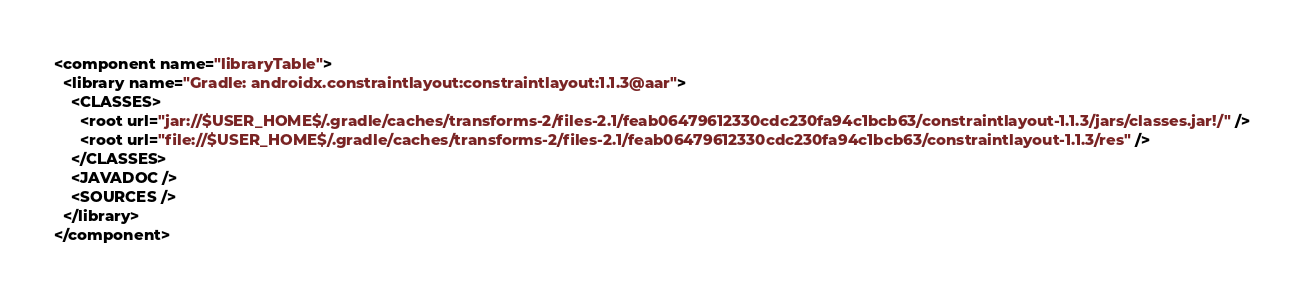Convert code to text. <code><loc_0><loc_0><loc_500><loc_500><_XML_><component name="libraryTable">
  <library name="Gradle: androidx.constraintlayout:constraintlayout:1.1.3@aar">
    <CLASSES>
      <root url="jar://$USER_HOME$/.gradle/caches/transforms-2/files-2.1/feab06479612330cdc230fa94c1bcb63/constraintlayout-1.1.3/jars/classes.jar!/" />
      <root url="file://$USER_HOME$/.gradle/caches/transforms-2/files-2.1/feab06479612330cdc230fa94c1bcb63/constraintlayout-1.1.3/res" />
    </CLASSES>
    <JAVADOC />
    <SOURCES />
  </library>
</component></code> 